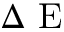Convert formula to latex. <formula><loc_0><loc_0><loc_500><loc_500>\Delta E</formula> 